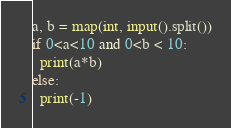Convert code to text. <code><loc_0><loc_0><loc_500><loc_500><_Python_>a, b = map(int, input().split())
if 0<a<10 and 0<b < 10:
  print(a*b)
else:
  print(-1)</code> 